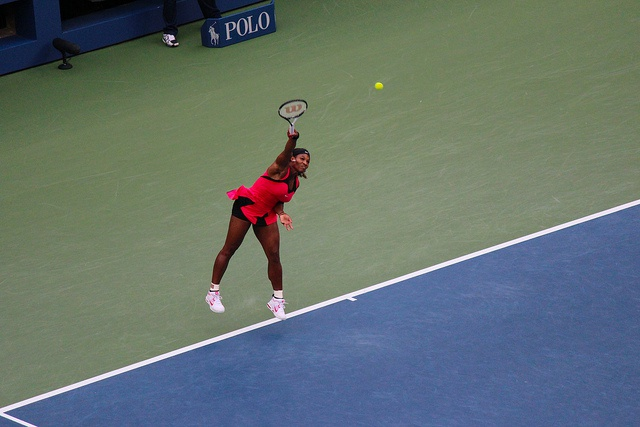Describe the objects in this image and their specific colors. I can see people in navy, black, maroon, and brown tones, people in navy, black, gray, and lavender tones, tennis racket in navy, darkgray, gray, and black tones, and sports ball in navy, yellow, olive, and khaki tones in this image. 